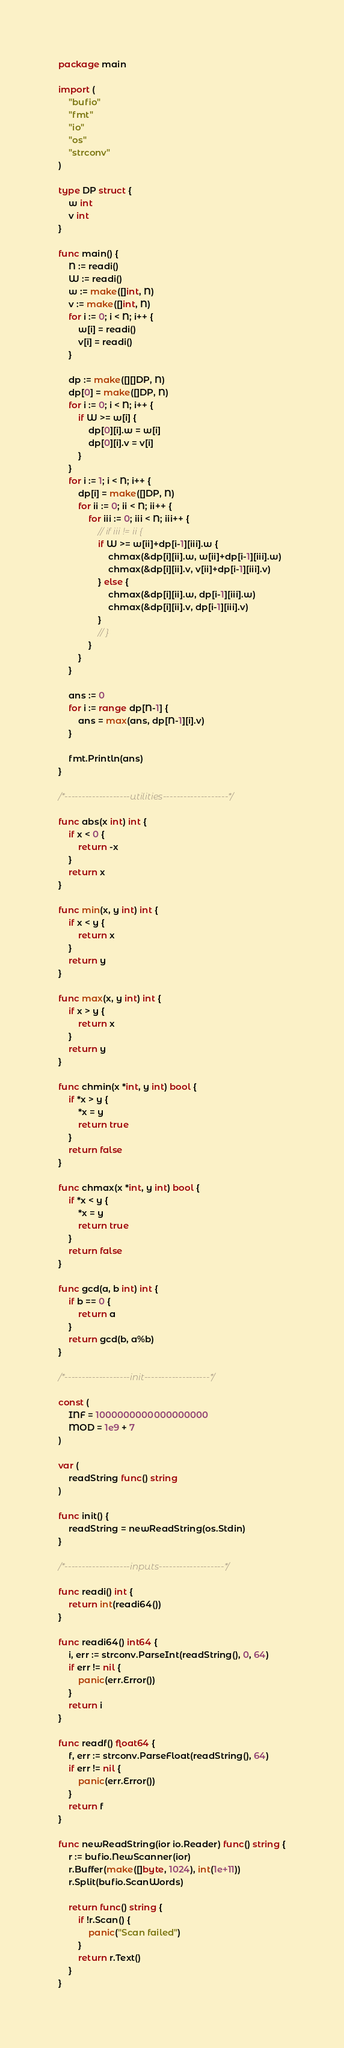<code> <loc_0><loc_0><loc_500><loc_500><_Go_>package main

import (
	"bufio"
	"fmt"
	"io"
	"os"
	"strconv"
)

type DP struct {
	w int
	v int
}

func main() {
	N := readi()
	W := readi()
	w := make([]int, N)
	v := make([]int, N)
	for i := 0; i < N; i++ {
		w[i] = readi()
		v[i] = readi()
	}

	dp := make([][]DP, N)
	dp[0] = make([]DP, N)
	for i := 0; i < N; i++ {
		if W >= w[i] {
			dp[0][i].w = w[i]
			dp[0][i].v = v[i]
		}
	}
	for i := 1; i < N; i++ {
		dp[i] = make([]DP, N)
		for ii := 0; ii < N; ii++ {
			for iii := 0; iii < N; iii++ {
				// if iii != ii {
				if W >= w[ii]+dp[i-1][iii].w {
					chmax(&dp[i][ii].w, w[ii]+dp[i-1][iii].w)
					chmax(&dp[i][ii].v, v[ii]+dp[i-1][iii].v)
				} else {
					chmax(&dp[i][ii].w, dp[i-1][iii].w)
					chmax(&dp[i][ii].v, dp[i-1][iii].v)
				}
				// }
			}
		}
	}

	ans := 0
	for i := range dp[N-1] {
		ans = max(ans, dp[N-1][i].v)
	}

	fmt.Println(ans)
}

/*-------------------utilities-------------------*/

func abs(x int) int {
	if x < 0 {
		return -x
	}
	return x
}

func min(x, y int) int {
	if x < y {
		return x
	}
	return y
}

func max(x, y int) int {
	if x > y {
		return x
	}
	return y
}

func chmin(x *int, y int) bool {
	if *x > y {
		*x = y
		return true
	}
	return false
}

func chmax(x *int, y int) bool {
	if *x < y {
		*x = y
		return true
	}
	return false
}

func gcd(a, b int) int {
	if b == 0 {
		return a
	}
	return gcd(b, a%b)
}

/*-------------------init-------------------*/

const (
	INF = 1000000000000000000
	MOD = 1e9 + 7
)

var (
	readString func() string
)

func init() {
	readString = newReadString(os.Stdin)
}

/*-------------------inputs-------------------*/

func readi() int {
	return int(readi64())
}

func readi64() int64 {
	i, err := strconv.ParseInt(readString(), 0, 64)
	if err != nil {
		panic(err.Error())
	}
	return i
}

func readf() float64 {
	f, err := strconv.ParseFloat(readString(), 64)
	if err != nil {
		panic(err.Error())
	}
	return f
}

func newReadString(ior io.Reader) func() string {
	r := bufio.NewScanner(ior)
	r.Buffer(make([]byte, 1024), int(1e+11))
	r.Split(bufio.ScanWords)

	return func() string {
		if !r.Scan() {
			panic("Scan failed")
		}
		return r.Text()
	}
}
</code> 